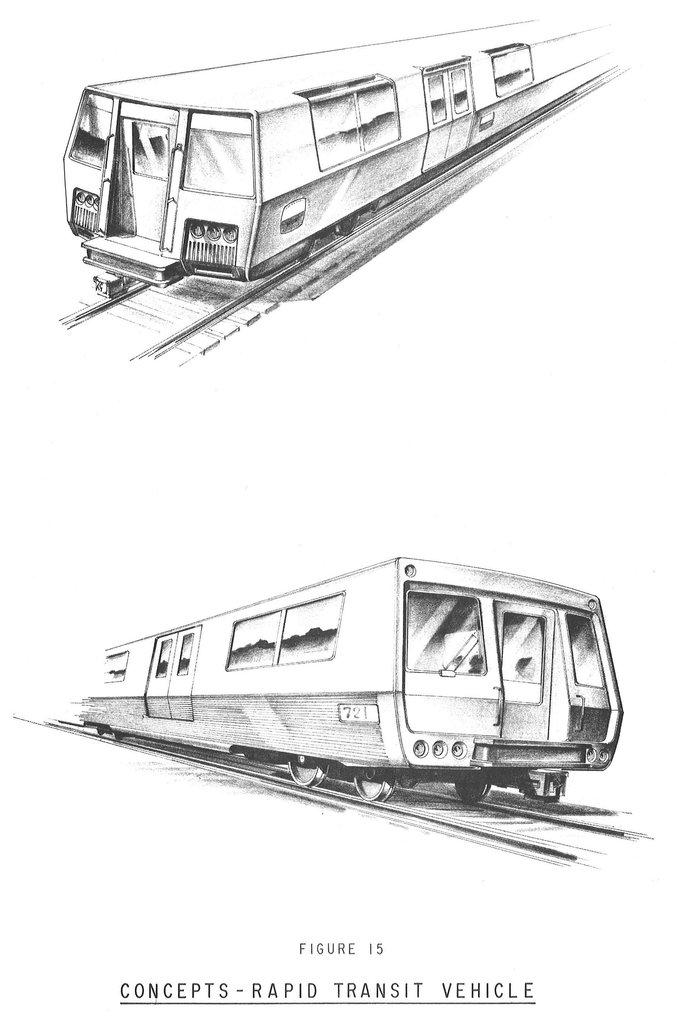What is the main subject of the image? The main subject of the image is a depiction of trains. What else is present in the image besides the trains? There is text on a white background in the image. What type of wire is being used to tie the shoes in the image? There are no shoes or wire present in the image; it features a depiction of trains and text on a white background. 